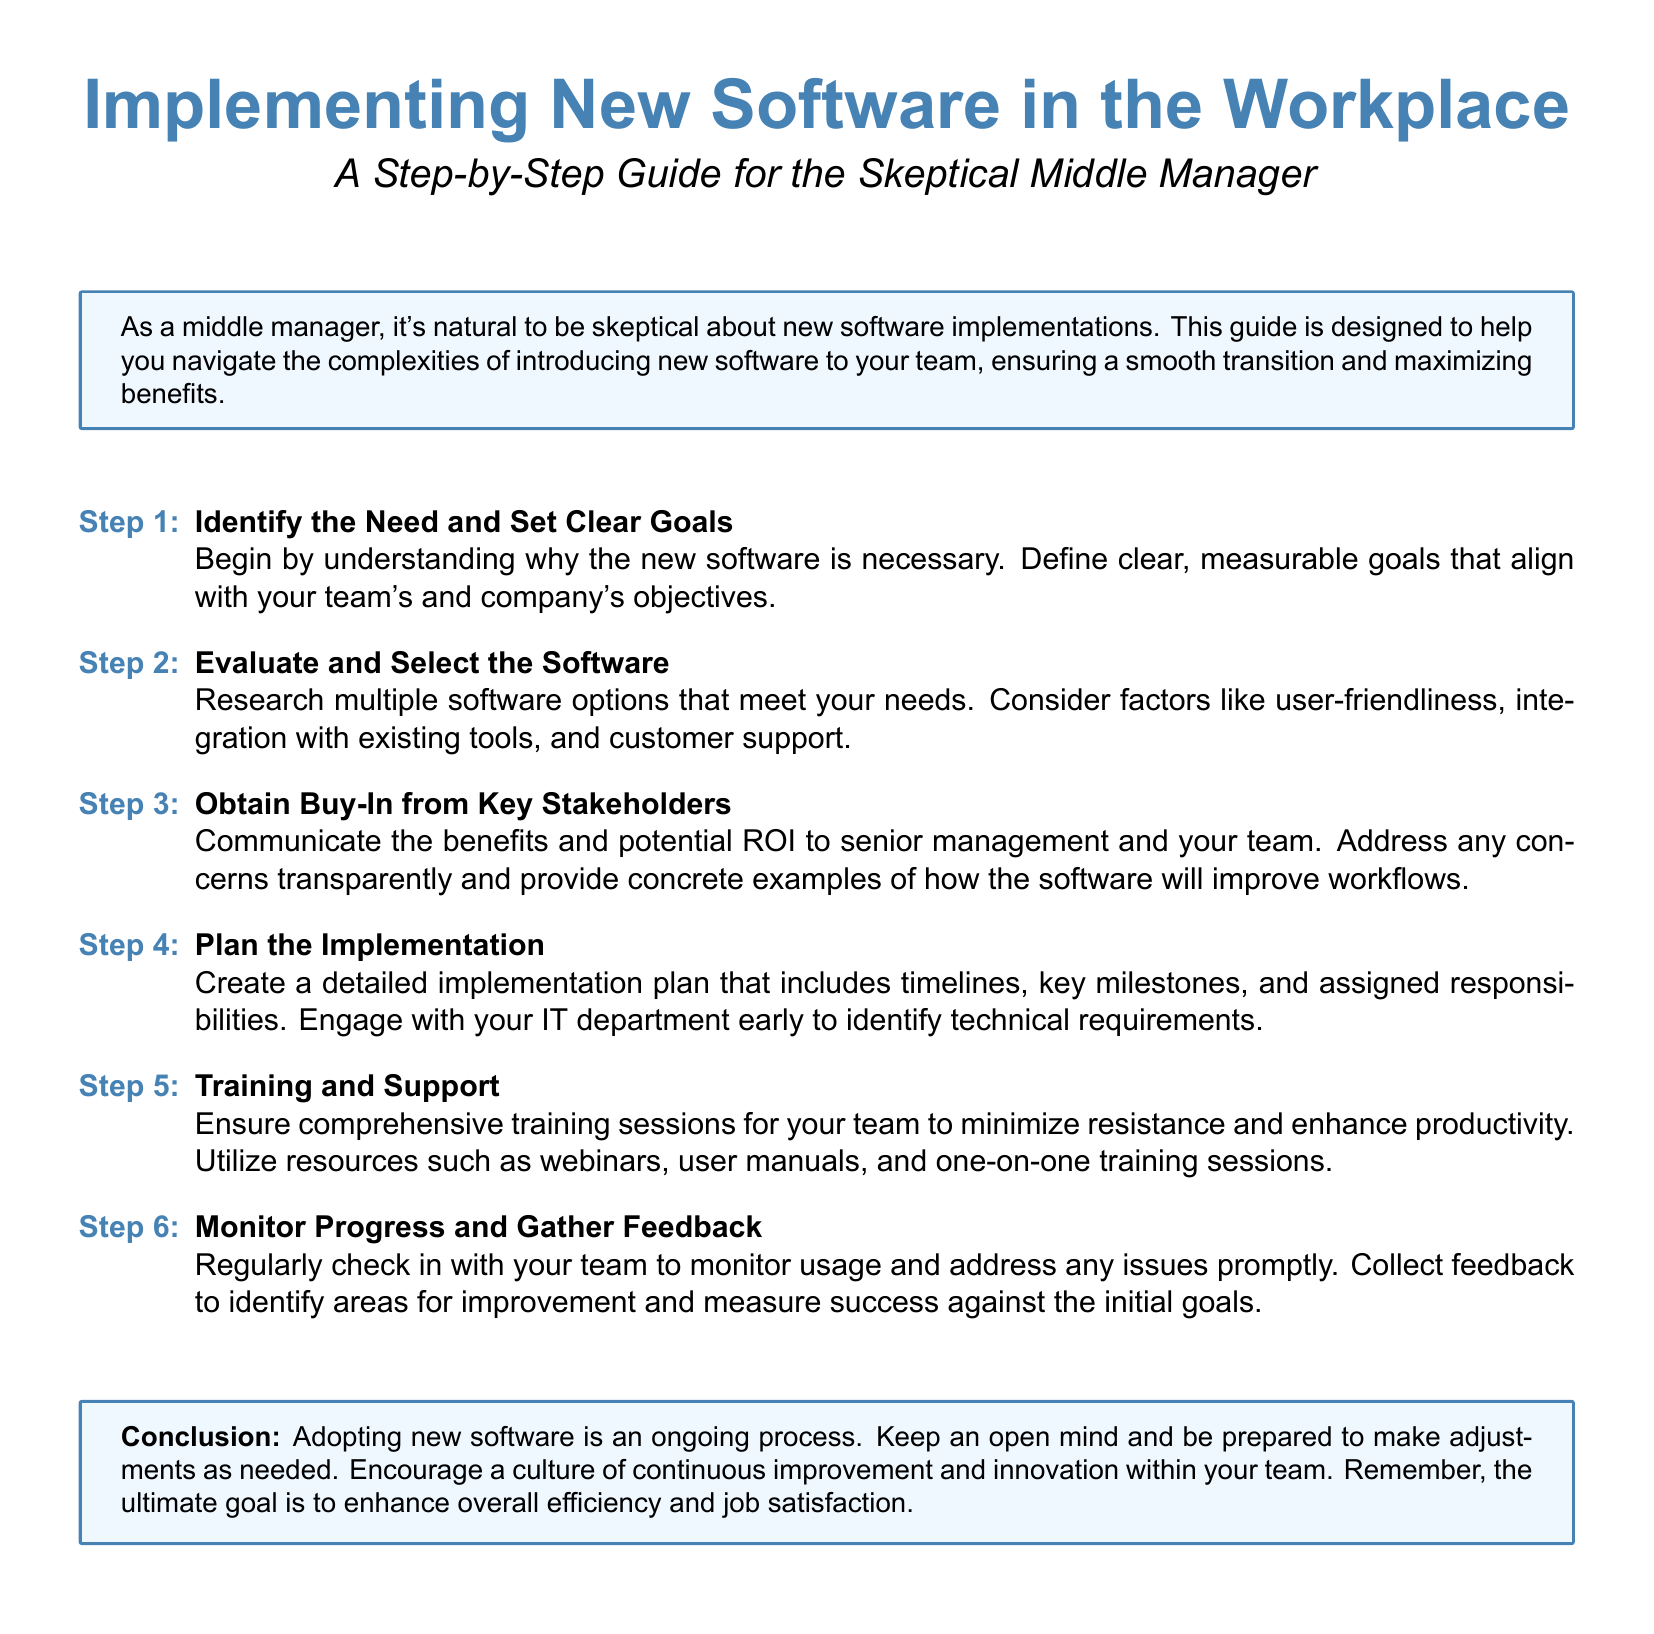What is the title of the guide? The title of the guide is prominently displayed at the top of the document.
Answer: Implementing New Software in the Workplace How many steps are included in the guide? The guide enumerates each step clearly in a list format.
Answer: Six steps What is the first step in the implementation process? The first item in the enumerated list specifies the initial action to take.
Answer: Identify the Need and Set Clear Goals What should be evaluated while selecting software? The text outlines key considerations for software selection.
Answer: User-friendliness Which department should be engaged early in the planning stage? The document specifies an important stakeholder in the implementation process.
Answer: IT department What type of training resources are suggested? The guide lists types of resources that can be utilized for training.
Answer: Webinars What is the ultimate goal of adopting new software as stated in the conclusion? The conclusion summarizes the wider intent behind the software adoption.
Answer: Enhance overall efficiency What is emphasized as part of the monitoring process? The document advises on the ongoing nature of implementation efforts.
Answer: Gather Feedback 